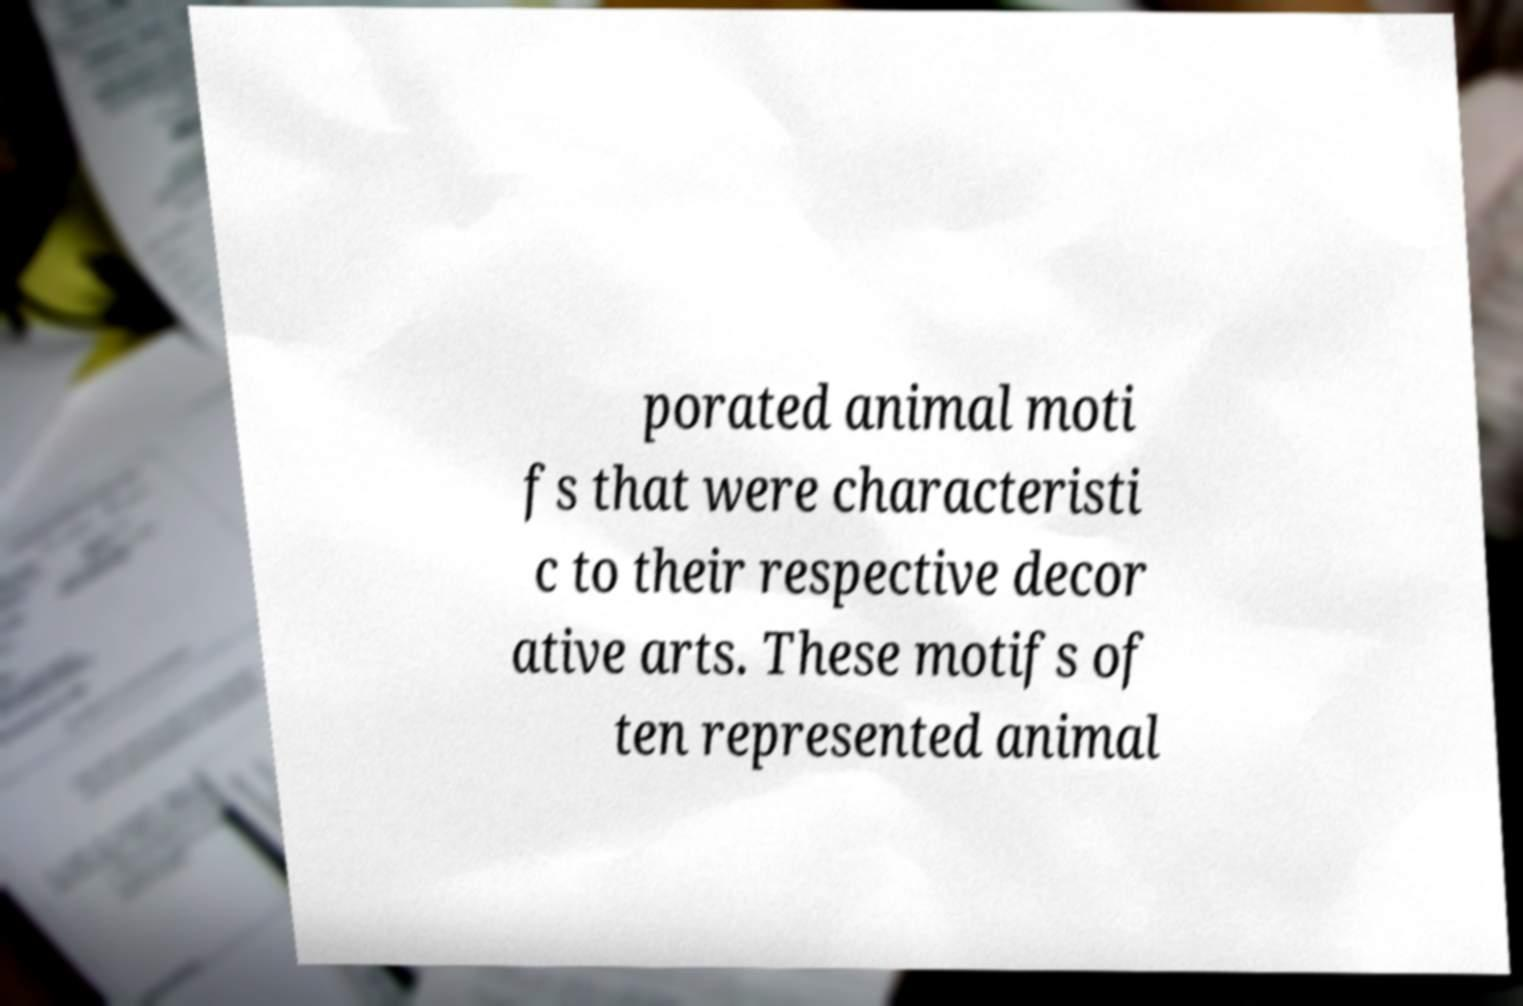Could you extract and type out the text from this image? porated animal moti fs that were characteristi c to their respective decor ative arts. These motifs of ten represented animal 